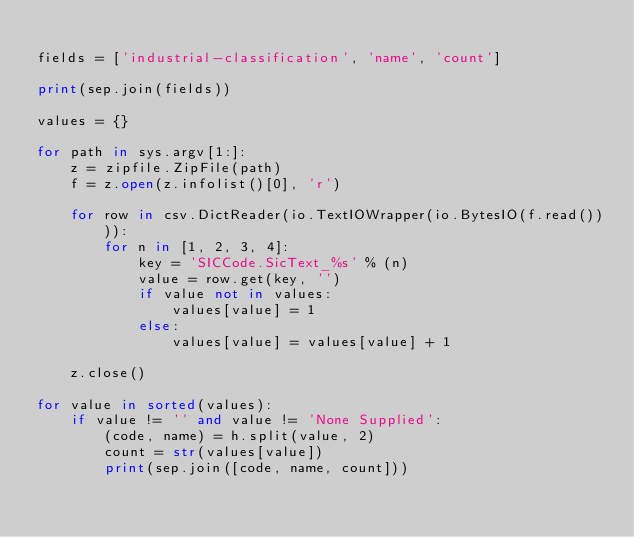Convert code to text. <code><loc_0><loc_0><loc_500><loc_500><_Python_>
fields = ['industrial-classification', 'name', 'count']

print(sep.join(fields))

values = {}

for path in sys.argv[1:]:
    z = zipfile.ZipFile(path)
    f = z.open(z.infolist()[0], 'r')

    for row in csv.DictReader(io.TextIOWrapper(io.BytesIO(f.read()))):
        for n in [1, 2, 3, 4]:
            key = 'SICCode.SicText_%s' % (n)
            value = row.get(key, '')
            if value not in values:
                values[value] = 1
            else:
                values[value] = values[value] + 1

    z.close()

for value in sorted(values):
    if value != '' and value != 'None Supplied':
        (code, name) = h.split(value, 2)
        count = str(values[value])
        print(sep.join([code, name, count]))
</code> 